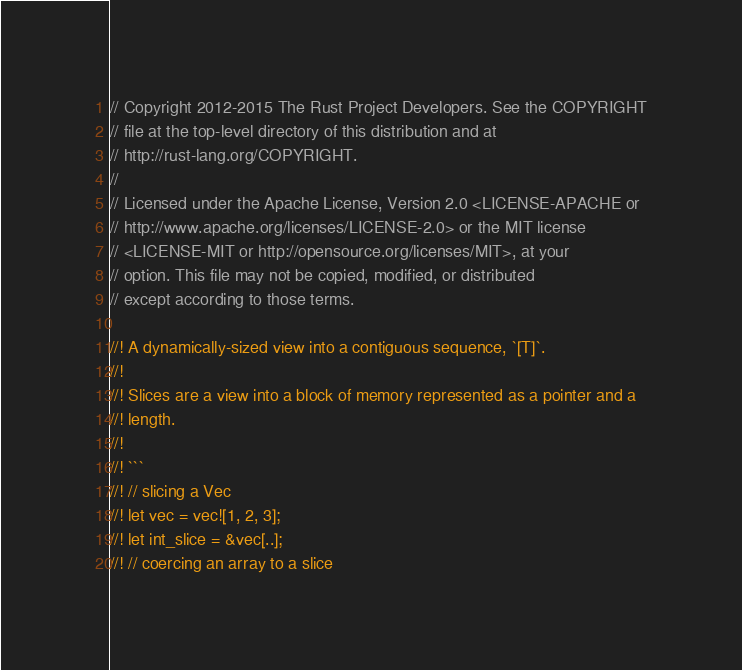Convert code to text. <code><loc_0><loc_0><loc_500><loc_500><_Rust_>// Copyright 2012-2015 The Rust Project Developers. See the COPYRIGHT
// file at the top-level directory of this distribution and at
// http://rust-lang.org/COPYRIGHT.
//
// Licensed under the Apache License, Version 2.0 <LICENSE-APACHE or
// http://www.apache.org/licenses/LICENSE-2.0> or the MIT license
// <LICENSE-MIT or http://opensource.org/licenses/MIT>, at your
// option. This file may not be copied, modified, or distributed
// except according to those terms.

//! A dynamically-sized view into a contiguous sequence, `[T]`.
//!
//! Slices are a view into a block of memory represented as a pointer and a
//! length.
//!
//! ```
//! // slicing a Vec
//! let vec = vec![1, 2, 3];
//! let int_slice = &vec[..];
//! // coercing an array to a slice</code> 